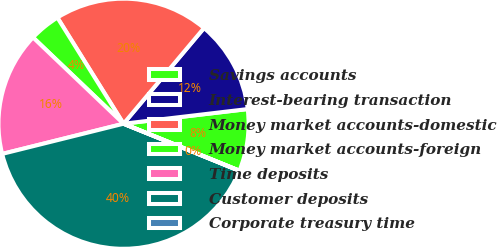Convert chart. <chart><loc_0><loc_0><loc_500><loc_500><pie_chart><fcel>Savings accounts<fcel>Interest-bearing transaction<fcel>Money market accounts-domestic<fcel>Money market accounts-foreign<fcel>Time deposits<fcel>Customer deposits<fcel>Corporate treasury time<nl><fcel>8.0%<fcel>12.0%<fcel>20.0%<fcel>4.01%<fcel>16.0%<fcel>39.98%<fcel>0.01%<nl></chart> 